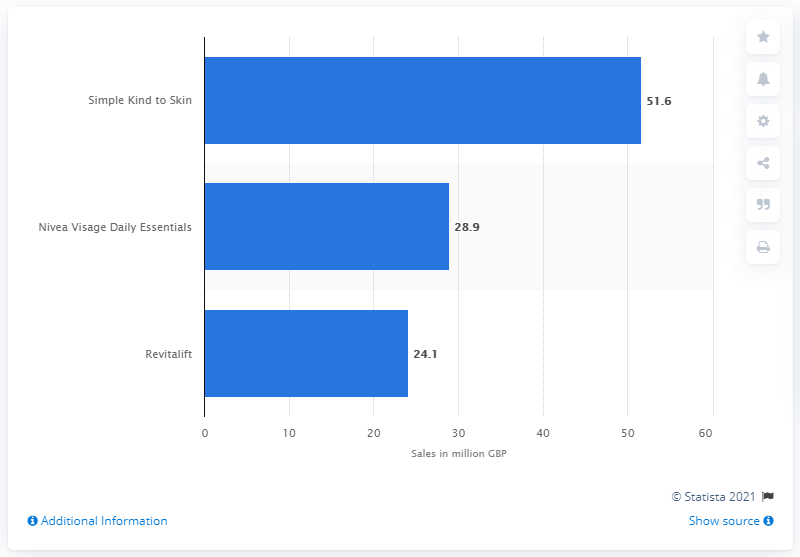Specify some key components in this picture. The total sales of Simple Kind to Skin in the year ending December 2014 were 51.6 million. In the year ending December 2014, the number one brand sold in the UK was Simple Kind to Skin. 